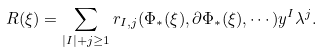<formula> <loc_0><loc_0><loc_500><loc_500>R ( \xi ) = \sum _ { | I | + j \geq 1 } r _ { I , j } ( \Phi _ { * } ( \xi ) , \partial \Phi _ { * } ( \xi ) , \cdots ) y ^ { I } \lambda ^ { j } .</formula> 